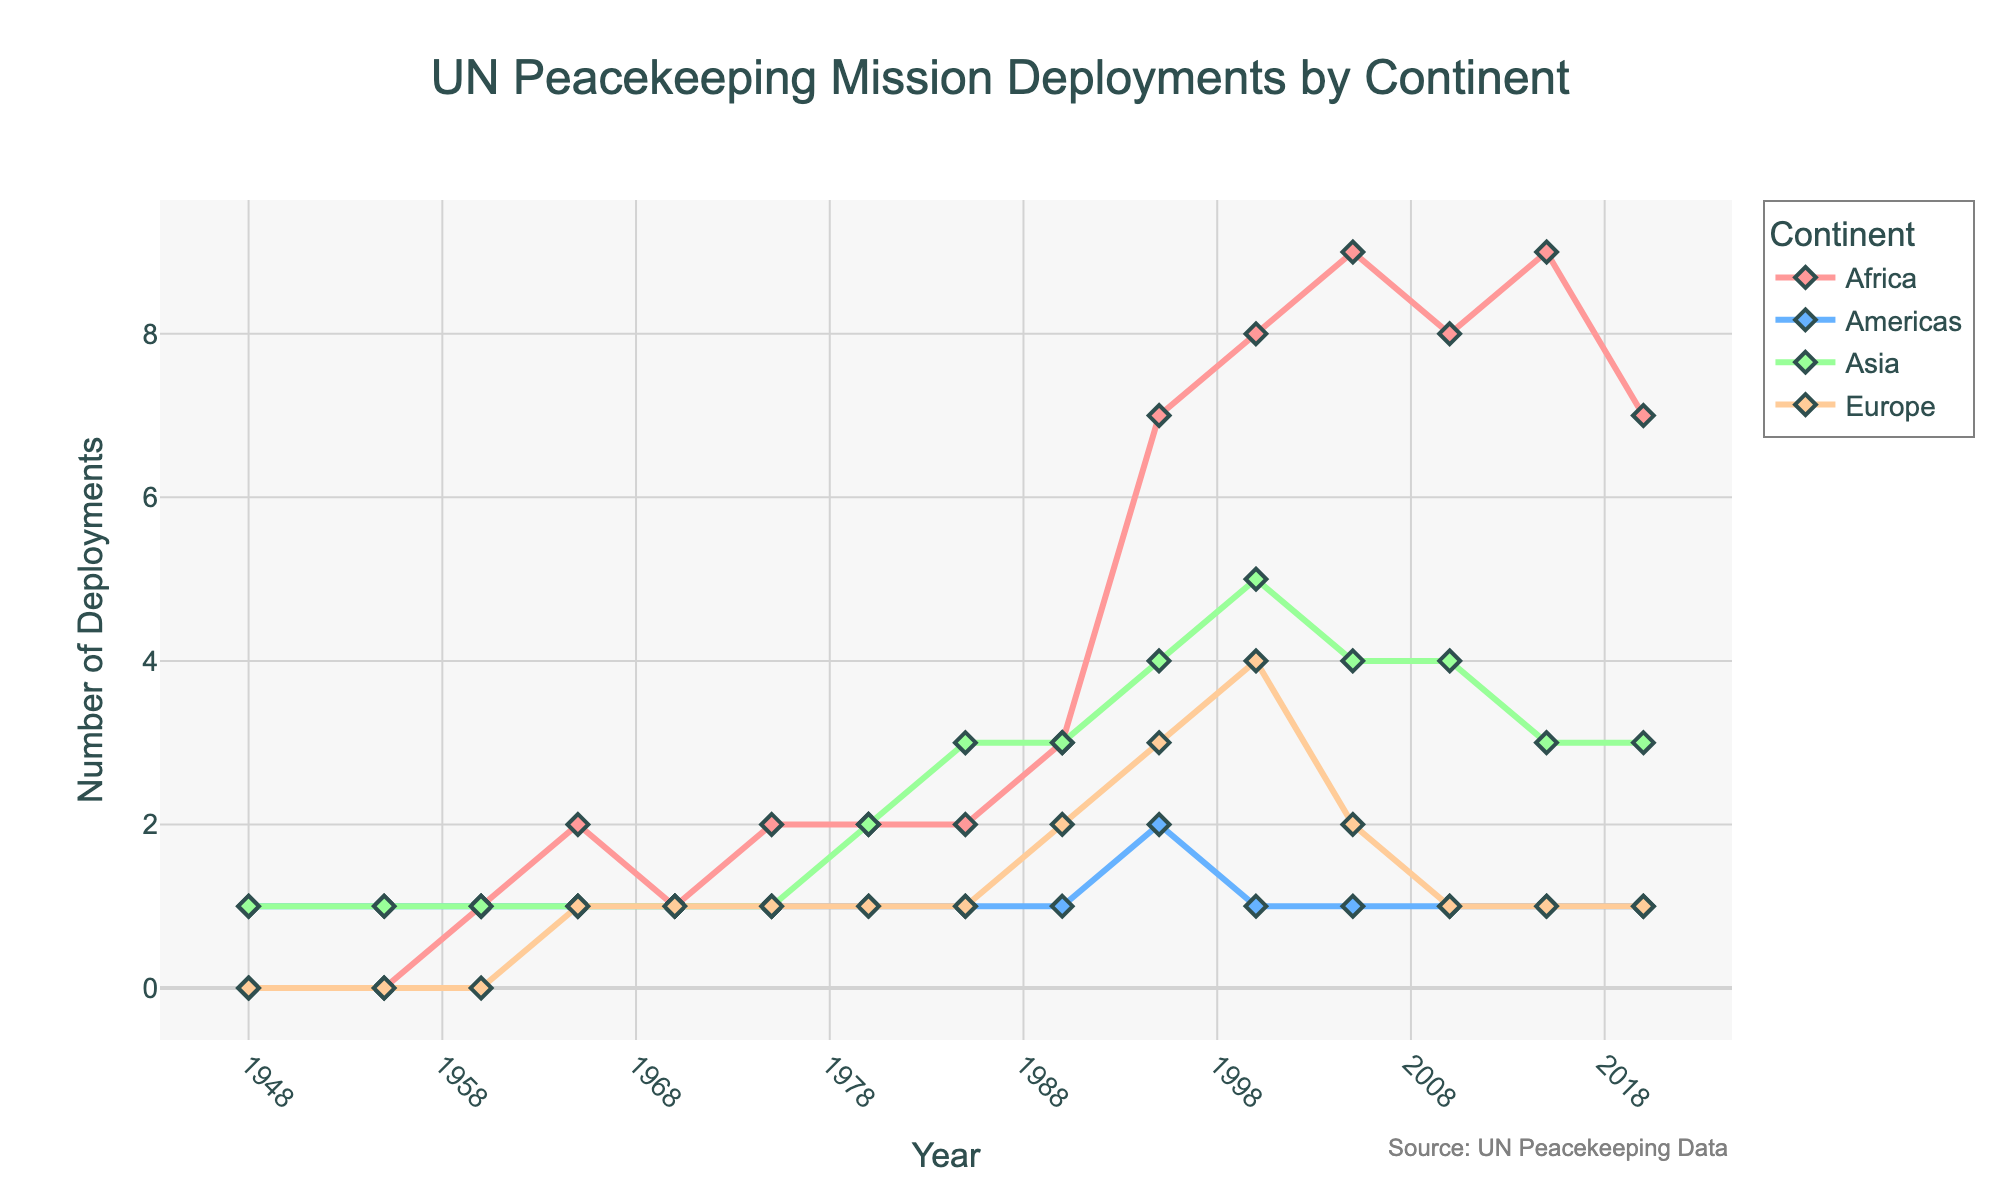What is the trend in the number of UN peacekeeping deployments in Africa from 1948 to 2020? Observe the line for Africa in the chart. It starts at 0 in 1948, gradually increases over the years, peaks at 9 in the 2000s, and slightly declines to 7 in 2020.
Answer: It shows an increasing trend with a peak in the 2000s In which year did Europe have the highest number of peacekeeping deployments? Look at the line for Europe. The highest point is at the year 2000, where it reaches 4 deployments.
Answer: 2000 How many more deployments were there in Asia compared to the Americas in 1985? Check the values for Asia and Americas in 1985. Asia has 3 deployments and Americas have 1 deployment. The difference is 3 - 1 = 2.
Answer: 2 During which decade did Asia first surpass 2 deployments? Observe the plot for Asia. It first surpasses 2 deployments around the mid-1980s.
Answer: 1980s How do the number of deployments in Africa and Europe compare in 2010? Check the values for Africa and Europe in 2010. Africa has 8 deployments while Europe has 1 deployment. Clearly, Africa has more.
Answer: Africa has more Calculate the average number of deployments in the Americas from 1948 to 2020. Sum the deployments in the Americas over the years (1+1+1+1+1+1+1+1+1+2+1+1+1+1) = 15. There are 14 years, so the average is 15/14 ≈ 1.07.
Answer: 1.07 Which continent had the most consistent number of deployments throughout the observed period? Evaluate the variability of each continent's line. The Americas consistently have around 1 deployment with minor deviations.
Answer: Americas Between 1995 and 2005, which continent experienced the largest increase in deployments? Compare the data points for 1995 and 2005 for each continent. Africa increased from 7 to 9, Americas remained the same, Asia remained the same, and Europe decreased. Africa had the largest increase (9-7=2).
Answer: Africa What is the total number of deployments for all continents in the year 2000? Sum the number of deployments for each continent in 2000 (8 in Africa + 1 in Americas + 5 in Asia + 4 in Europe). 8 + 1 + 5 + 4 = 18.
Answer: 18 From which year did Africa start to have more deployments than any other continent? Scan through the years and compare Africa's line to others. From 1990 onwards, Africa consistently has more deployments.
Answer: 1990 